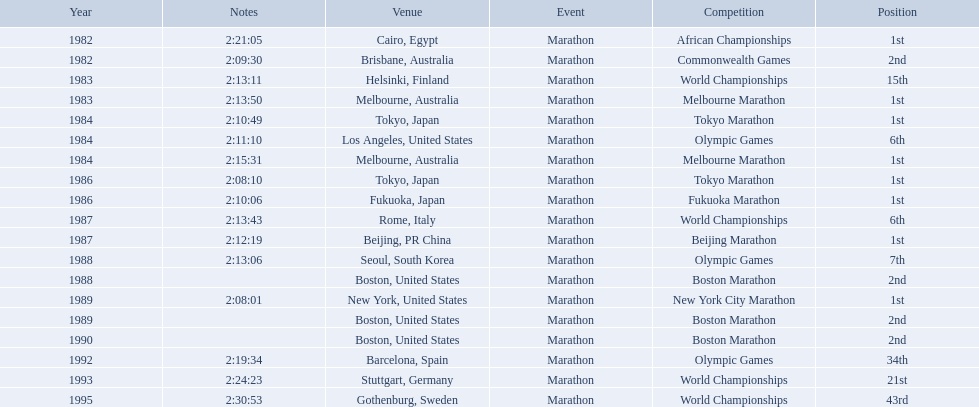What are all of the juma ikangaa competitions? African Championships, Commonwealth Games, World Championships, Melbourne Marathon, Tokyo Marathon, Olympic Games, Melbourne Marathon, Tokyo Marathon, Fukuoka Marathon, World Championships, Beijing Marathon, Olympic Games, Boston Marathon, New York City Marathon, Boston Marathon, Boston Marathon, Olympic Games, World Championships, World Championships. Which of these competitions did not take place in the united states? African Championships, Commonwealth Games, World Championships, Melbourne Marathon, Tokyo Marathon, Melbourne Marathon, Tokyo Marathon, Fukuoka Marathon, World Championships, Beijing Marathon, Olympic Games, Olympic Games, World Championships, World Championships. Out of these, which of them took place in asia? Tokyo Marathon, Tokyo Marathon, Fukuoka Marathon, Beijing Marathon, Olympic Games. Which of the remaining competitions took place in china? Beijing Marathon. 